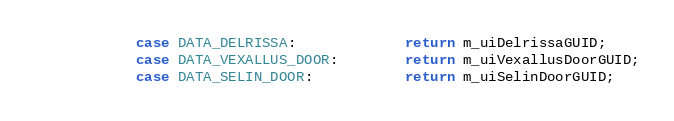Convert code to text. <code><loc_0><loc_0><loc_500><loc_500><_C++_>            case DATA_DELRISSA:             return m_uiDelrissaGUID;
            case DATA_VEXALLUS_DOOR:        return m_uiVexallusDoorGUID;
            case DATA_SELIN_DOOR:           return m_uiSelinDoorGUID;</code> 